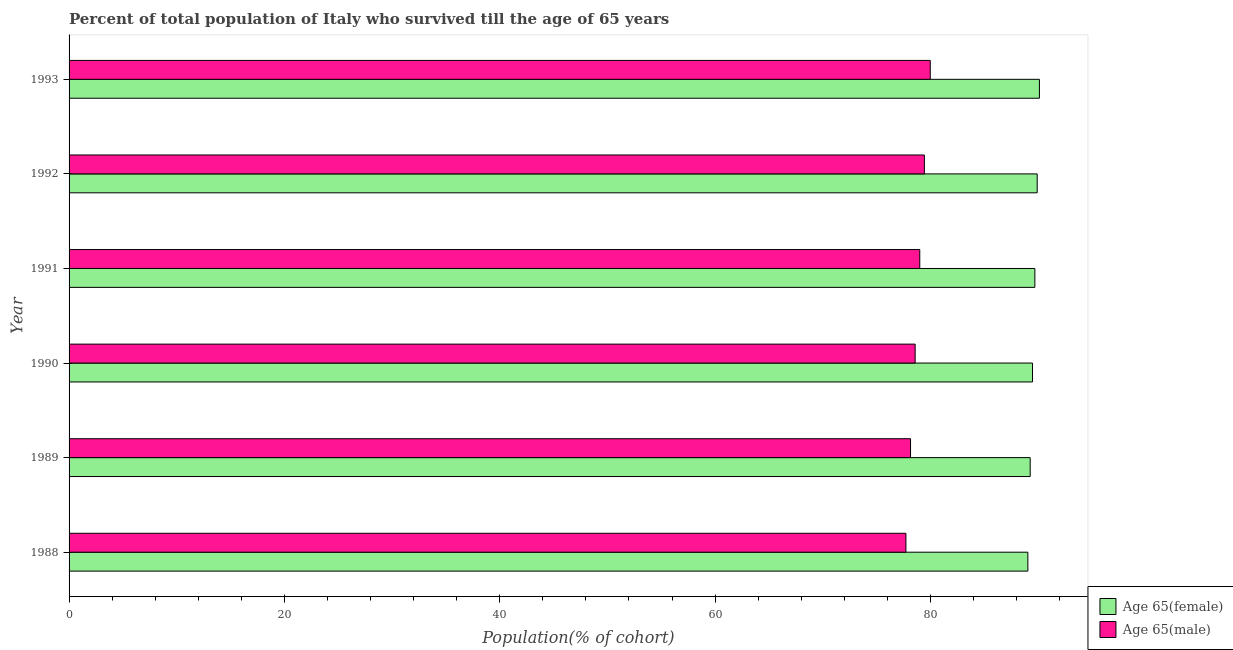How many different coloured bars are there?
Provide a short and direct response. 2. Are the number of bars on each tick of the Y-axis equal?
Make the answer very short. Yes. How many bars are there on the 6th tick from the top?
Your answer should be compact. 2. How many bars are there on the 6th tick from the bottom?
Your response must be concise. 2. What is the percentage of female population who survived till age of 65 in 1990?
Provide a short and direct response. 89.49. Across all years, what is the maximum percentage of male population who survived till age of 65?
Offer a terse response. 79.99. Across all years, what is the minimum percentage of female population who survived till age of 65?
Provide a short and direct response. 89.05. In which year was the percentage of female population who survived till age of 65 maximum?
Ensure brevity in your answer.  1993. What is the total percentage of female population who survived till age of 65 in the graph?
Offer a very short reply. 537.56. What is the difference between the percentage of male population who survived till age of 65 in 1988 and that in 1989?
Give a very brief answer. -0.43. What is the difference between the percentage of female population who survived till age of 65 in 1992 and the percentage of male population who survived till age of 65 in 1993?
Offer a very short reply. 9.93. What is the average percentage of female population who survived till age of 65 per year?
Keep it short and to the point. 89.59. In the year 1988, what is the difference between the percentage of female population who survived till age of 65 and percentage of male population who survived till age of 65?
Give a very brief answer. 11.33. What is the ratio of the percentage of female population who survived till age of 65 in 1988 to that in 1992?
Your response must be concise. 0.99. What is the difference between the highest and the second highest percentage of male population who survived till age of 65?
Your response must be concise. 0.55. What is the difference between the highest and the lowest percentage of male population who survived till age of 65?
Keep it short and to the point. 2.26. In how many years, is the percentage of male population who survived till age of 65 greater than the average percentage of male population who survived till age of 65 taken over all years?
Keep it short and to the point. 3. What does the 1st bar from the top in 1988 represents?
Your response must be concise. Age 65(male). What does the 2nd bar from the bottom in 1989 represents?
Provide a short and direct response. Age 65(male). Are all the bars in the graph horizontal?
Provide a short and direct response. Yes. How many years are there in the graph?
Offer a very short reply. 6. Are the values on the major ticks of X-axis written in scientific E-notation?
Make the answer very short. No. Does the graph contain any zero values?
Offer a very short reply. No. Does the graph contain grids?
Ensure brevity in your answer.  No. Where does the legend appear in the graph?
Your response must be concise. Bottom right. How many legend labels are there?
Your answer should be very brief. 2. How are the legend labels stacked?
Keep it short and to the point. Vertical. What is the title of the graph?
Make the answer very short. Percent of total population of Italy who survived till the age of 65 years. What is the label or title of the X-axis?
Offer a very short reply. Population(% of cohort). What is the Population(% of cohort) in Age 65(female) in 1988?
Your response must be concise. 89.05. What is the Population(% of cohort) in Age 65(male) in 1988?
Offer a terse response. 77.73. What is the Population(% of cohort) in Age 65(female) in 1989?
Your response must be concise. 89.27. What is the Population(% of cohort) in Age 65(male) in 1989?
Offer a terse response. 78.16. What is the Population(% of cohort) of Age 65(female) in 1990?
Offer a terse response. 89.49. What is the Population(% of cohort) in Age 65(male) in 1990?
Offer a very short reply. 78.58. What is the Population(% of cohort) in Age 65(female) in 1991?
Ensure brevity in your answer.  89.7. What is the Population(% of cohort) in Age 65(male) in 1991?
Keep it short and to the point. 79.01. What is the Population(% of cohort) of Age 65(female) in 1992?
Offer a terse response. 89.92. What is the Population(% of cohort) of Age 65(male) in 1992?
Keep it short and to the point. 79.44. What is the Population(% of cohort) in Age 65(female) in 1993?
Your answer should be compact. 90.13. What is the Population(% of cohort) of Age 65(male) in 1993?
Ensure brevity in your answer.  79.99. Across all years, what is the maximum Population(% of cohort) of Age 65(female)?
Give a very brief answer. 90.13. Across all years, what is the maximum Population(% of cohort) of Age 65(male)?
Give a very brief answer. 79.99. Across all years, what is the minimum Population(% of cohort) of Age 65(female)?
Make the answer very short. 89.05. Across all years, what is the minimum Population(% of cohort) in Age 65(male)?
Keep it short and to the point. 77.73. What is the total Population(% of cohort) in Age 65(female) in the graph?
Offer a very short reply. 537.56. What is the total Population(% of cohort) of Age 65(male) in the graph?
Your response must be concise. 472.91. What is the difference between the Population(% of cohort) in Age 65(female) in 1988 and that in 1989?
Provide a short and direct response. -0.22. What is the difference between the Population(% of cohort) in Age 65(male) in 1988 and that in 1989?
Your answer should be compact. -0.43. What is the difference between the Population(% of cohort) in Age 65(female) in 1988 and that in 1990?
Provide a succinct answer. -0.43. What is the difference between the Population(% of cohort) in Age 65(male) in 1988 and that in 1990?
Give a very brief answer. -0.86. What is the difference between the Population(% of cohort) in Age 65(female) in 1988 and that in 1991?
Provide a short and direct response. -0.65. What is the difference between the Population(% of cohort) in Age 65(male) in 1988 and that in 1991?
Keep it short and to the point. -1.29. What is the difference between the Population(% of cohort) in Age 65(female) in 1988 and that in 1992?
Make the answer very short. -0.87. What is the difference between the Population(% of cohort) in Age 65(male) in 1988 and that in 1992?
Your answer should be very brief. -1.72. What is the difference between the Population(% of cohort) of Age 65(female) in 1988 and that in 1993?
Your answer should be very brief. -1.07. What is the difference between the Population(% of cohort) in Age 65(male) in 1988 and that in 1993?
Offer a very short reply. -2.26. What is the difference between the Population(% of cohort) of Age 65(female) in 1989 and that in 1990?
Provide a short and direct response. -0.22. What is the difference between the Population(% of cohort) in Age 65(male) in 1989 and that in 1990?
Give a very brief answer. -0.43. What is the difference between the Population(% of cohort) of Age 65(female) in 1989 and that in 1991?
Provide a short and direct response. -0.43. What is the difference between the Population(% of cohort) in Age 65(male) in 1989 and that in 1991?
Ensure brevity in your answer.  -0.86. What is the difference between the Population(% of cohort) of Age 65(female) in 1989 and that in 1992?
Your response must be concise. -0.65. What is the difference between the Population(% of cohort) of Age 65(male) in 1989 and that in 1992?
Provide a succinct answer. -1.29. What is the difference between the Population(% of cohort) of Age 65(female) in 1989 and that in 1993?
Offer a very short reply. -0.86. What is the difference between the Population(% of cohort) in Age 65(male) in 1989 and that in 1993?
Ensure brevity in your answer.  -1.83. What is the difference between the Population(% of cohort) in Age 65(female) in 1990 and that in 1991?
Keep it short and to the point. -0.22. What is the difference between the Population(% of cohort) of Age 65(male) in 1990 and that in 1991?
Offer a terse response. -0.43. What is the difference between the Population(% of cohort) in Age 65(female) in 1990 and that in 1992?
Offer a very short reply. -0.43. What is the difference between the Population(% of cohort) of Age 65(male) in 1990 and that in 1992?
Provide a short and direct response. -0.86. What is the difference between the Population(% of cohort) of Age 65(female) in 1990 and that in 1993?
Keep it short and to the point. -0.64. What is the difference between the Population(% of cohort) in Age 65(male) in 1990 and that in 1993?
Offer a terse response. -1.4. What is the difference between the Population(% of cohort) in Age 65(female) in 1991 and that in 1992?
Keep it short and to the point. -0.22. What is the difference between the Population(% of cohort) in Age 65(male) in 1991 and that in 1992?
Your response must be concise. -0.43. What is the difference between the Population(% of cohort) in Age 65(female) in 1991 and that in 1993?
Provide a succinct answer. -0.42. What is the difference between the Population(% of cohort) of Age 65(male) in 1991 and that in 1993?
Make the answer very short. -0.97. What is the difference between the Population(% of cohort) of Age 65(female) in 1992 and that in 1993?
Your answer should be very brief. -0.21. What is the difference between the Population(% of cohort) of Age 65(male) in 1992 and that in 1993?
Give a very brief answer. -0.54. What is the difference between the Population(% of cohort) in Age 65(female) in 1988 and the Population(% of cohort) in Age 65(male) in 1989?
Make the answer very short. 10.9. What is the difference between the Population(% of cohort) in Age 65(female) in 1988 and the Population(% of cohort) in Age 65(male) in 1990?
Your answer should be very brief. 10.47. What is the difference between the Population(% of cohort) of Age 65(female) in 1988 and the Population(% of cohort) of Age 65(male) in 1991?
Keep it short and to the point. 10.04. What is the difference between the Population(% of cohort) of Age 65(female) in 1988 and the Population(% of cohort) of Age 65(male) in 1992?
Keep it short and to the point. 9.61. What is the difference between the Population(% of cohort) in Age 65(female) in 1988 and the Population(% of cohort) in Age 65(male) in 1993?
Your answer should be very brief. 9.07. What is the difference between the Population(% of cohort) of Age 65(female) in 1989 and the Population(% of cohort) of Age 65(male) in 1990?
Your answer should be very brief. 10.68. What is the difference between the Population(% of cohort) of Age 65(female) in 1989 and the Population(% of cohort) of Age 65(male) in 1991?
Keep it short and to the point. 10.26. What is the difference between the Population(% of cohort) in Age 65(female) in 1989 and the Population(% of cohort) in Age 65(male) in 1992?
Provide a succinct answer. 9.83. What is the difference between the Population(% of cohort) in Age 65(female) in 1989 and the Population(% of cohort) in Age 65(male) in 1993?
Ensure brevity in your answer.  9.28. What is the difference between the Population(% of cohort) of Age 65(female) in 1990 and the Population(% of cohort) of Age 65(male) in 1991?
Your answer should be very brief. 10.47. What is the difference between the Population(% of cohort) in Age 65(female) in 1990 and the Population(% of cohort) in Age 65(male) in 1992?
Keep it short and to the point. 10.04. What is the difference between the Population(% of cohort) of Age 65(female) in 1990 and the Population(% of cohort) of Age 65(male) in 1993?
Offer a very short reply. 9.5. What is the difference between the Population(% of cohort) in Age 65(female) in 1991 and the Population(% of cohort) in Age 65(male) in 1992?
Make the answer very short. 10.26. What is the difference between the Population(% of cohort) of Age 65(female) in 1991 and the Population(% of cohort) of Age 65(male) in 1993?
Give a very brief answer. 9.72. What is the difference between the Population(% of cohort) of Age 65(female) in 1992 and the Population(% of cohort) of Age 65(male) in 1993?
Your answer should be compact. 9.93. What is the average Population(% of cohort) of Age 65(female) per year?
Offer a very short reply. 89.59. What is the average Population(% of cohort) of Age 65(male) per year?
Make the answer very short. 78.82. In the year 1988, what is the difference between the Population(% of cohort) of Age 65(female) and Population(% of cohort) of Age 65(male)?
Your response must be concise. 11.33. In the year 1989, what is the difference between the Population(% of cohort) in Age 65(female) and Population(% of cohort) in Age 65(male)?
Ensure brevity in your answer.  11.11. In the year 1990, what is the difference between the Population(% of cohort) of Age 65(female) and Population(% of cohort) of Age 65(male)?
Offer a terse response. 10.9. In the year 1991, what is the difference between the Population(% of cohort) of Age 65(female) and Population(% of cohort) of Age 65(male)?
Offer a very short reply. 10.69. In the year 1992, what is the difference between the Population(% of cohort) in Age 65(female) and Population(% of cohort) in Age 65(male)?
Your answer should be compact. 10.48. In the year 1993, what is the difference between the Population(% of cohort) of Age 65(female) and Population(% of cohort) of Age 65(male)?
Give a very brief answer. 10.14. What is the ratio of the Population(% of cohort) in Age 65(male) in 1988 to that in 1989?
Provide a short and direct response. 0.99. What is the ratio of the Population(% of cohort) in Age 65(female) in 1988 to that in 1991?
Provide a succinct answer. 0.99. What is the ratio of the Population(% of cohort) of Age 65(male) in 1988 to that in 1991?
Provide a short and direct response. 0.98. What is the ratio of the Population(% of cohort) of Age 65(male) in 1988 to that in 1992?
Provide a short and direct response. 0.98. What is the ratio of the Population(% of cohort) in Age 65(female) in 1988 to that in 1993?
Your response must be concise. 0.99. What is the ratio of the Population(% of cohort) of Age 65(male) in 1988 to that in 1993?
Your answer should be very brief. 0.97. What is the ratio of the Population(% of cohort) of Age 65(male) in 1989 to that in 1992?
Ensure brevity in your answer.  0.98. What is the ratio of the Population(% of cohort) in Age 65(female) in 1989 to that in 1993?
Your answer should be very brief. 0.99. What is the ratio of the Population(% of cohort) in Age 65(male) in 1989 to that in 1993?
Provide a short and direct response. 0.98. What is the ratio of the Population(% of cohort) in Age 65(female) in 1990 to that in 1991?
Offer a very short reply. 1. What is the ratio of the Population(% of cohort) in Age 65(female) in 1990 to that in 1992?
Keep it short and to the point. 1. What is the ratio of the Population(% of cohort) of Age 65(male) in 1990 to that in 1992?
Keep it short and to the point. 0.99. What is the ratio of the Population(% of cohort) in Age 65(female) in 1990 to that in 1993?
Your answer should be compact. 0.99. What is the ratio of the Population(% of cohort) of Age 65(male) in 1990 to that in 1993?
Offer a terse response. 0.98. What is the ratio of the Population(% of cohort) in Age 65(female) in 1991 to that in 1993?
Your response must be concise. 1. What is the difference between the highest and the second highest Population(% of cohort) of Age 65(female)?
Provide a short and direct response. 0.21. What is the difference between the highest and the second highest Population(% of cohort) of Age 65(male)?
Provide a short and direct response. 0.54. What is the difference between the highest and the lowest Population(% of cohort) of Age 65(female)?
Provide a short and direct response. 1.07. What is the difference between the highest and the lowest Population(% of cohort) in Age 65(male)?
Your answer should be very brief. 2.26. 